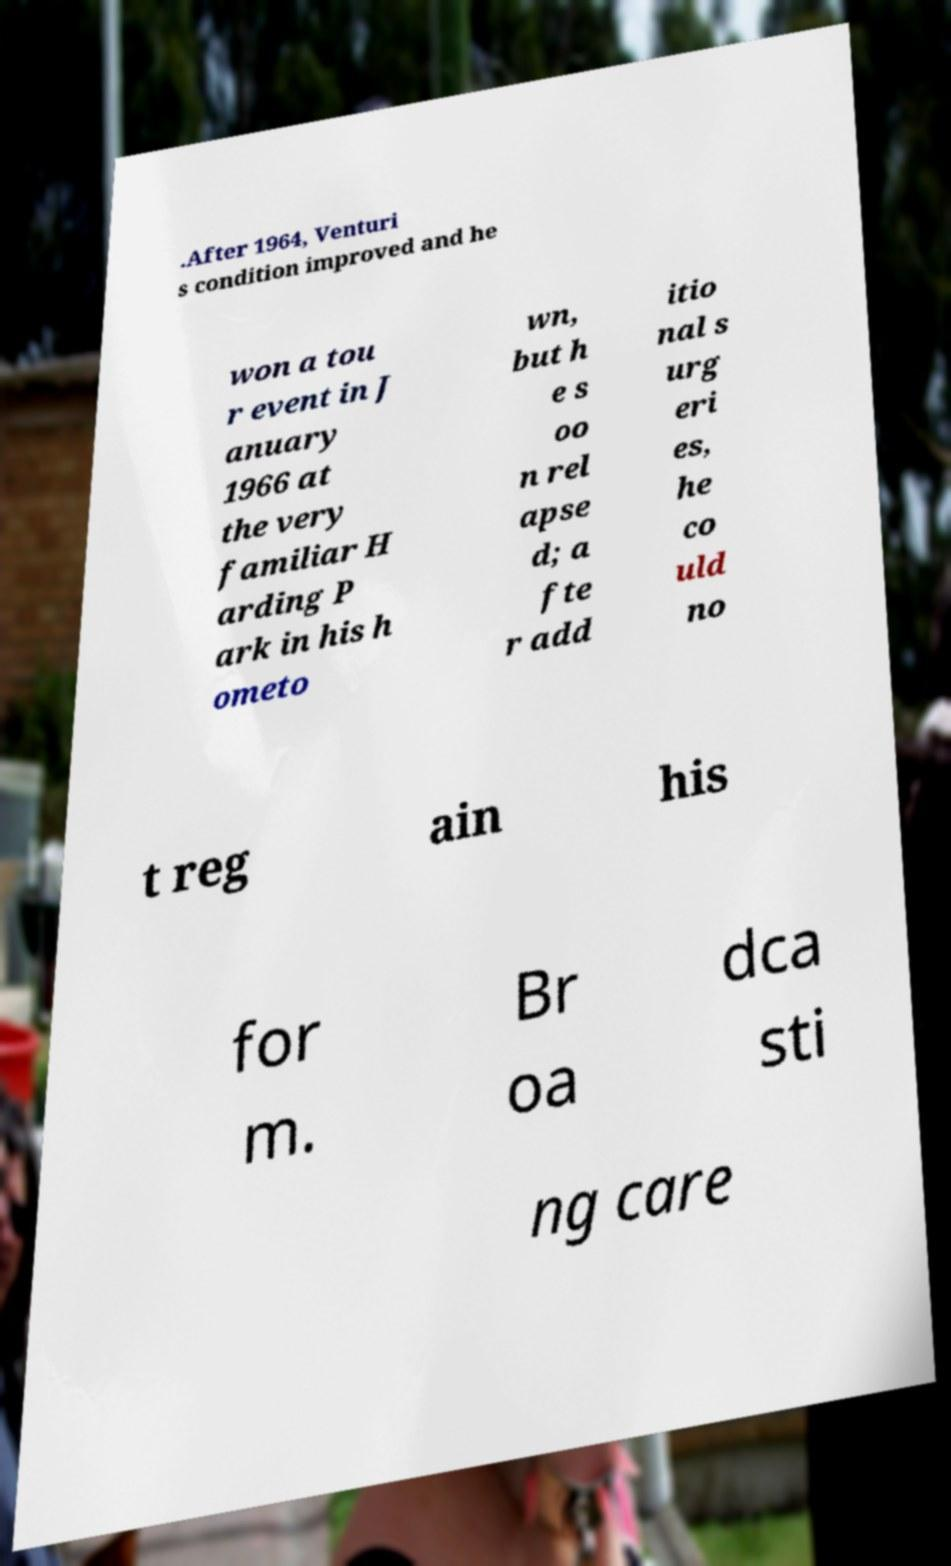Could you assist in decoding the text presented in this image and type it out clearly? .After 1964, Venturi s condition improved and he won a tou r event in J anuary 1966 at the very familiar H arding P ark in his h ometo wn, but h e s oo n rel apse d; a fte r add itio nal s urg eri es, he co uld no t reg ain his for m. Br oa dca sti ng care 